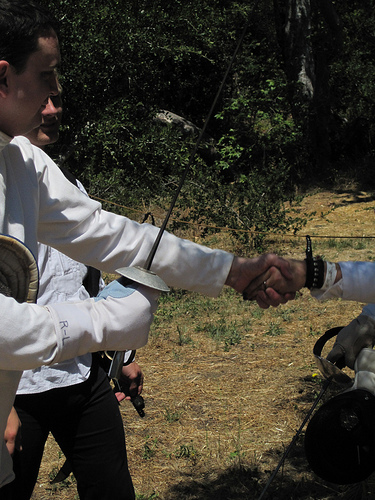<image>
Is there a women to the left of the man? Yes. From this viewpoint, the women is positioned to the left side relative to the man. Is the sward in the man hand? Yes. The sward is contained within or inside the man hand, showing a containment relationship. 